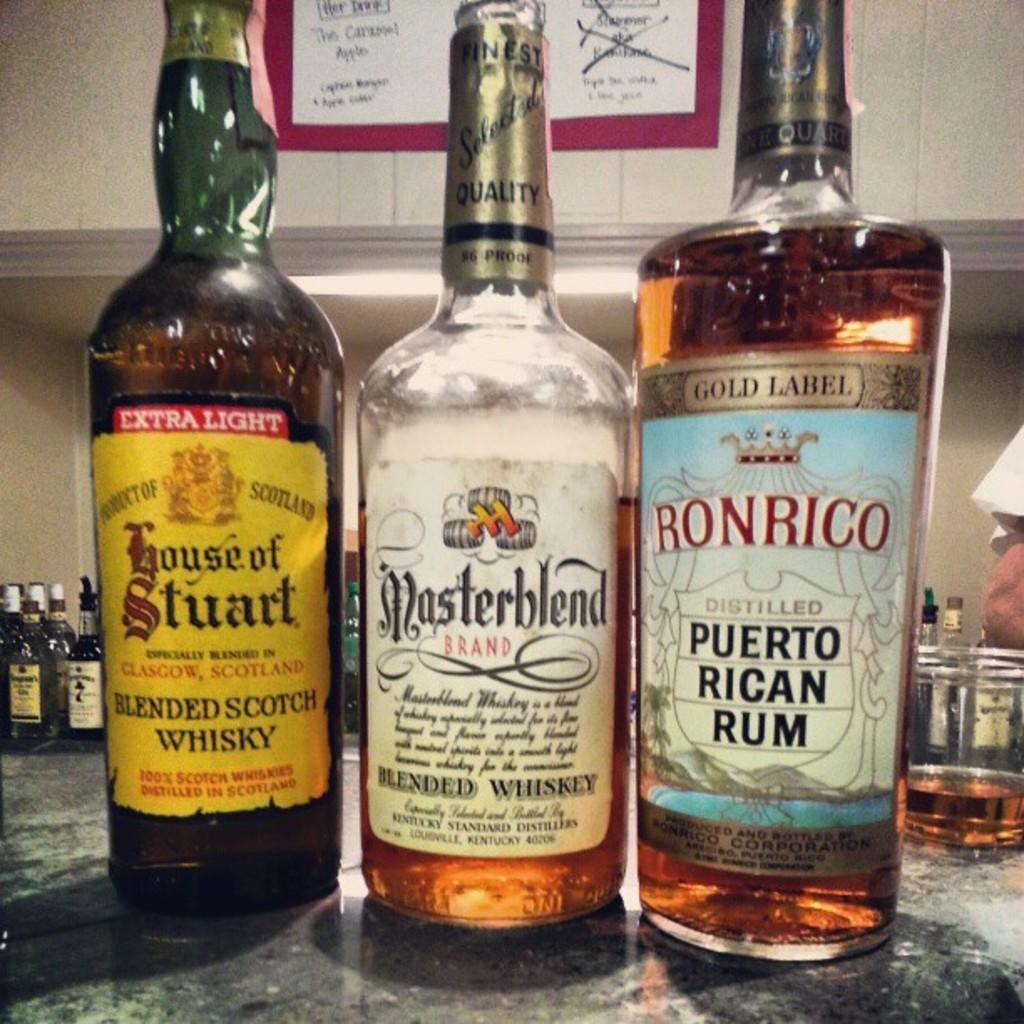<image>
Create a compact narrative representing the image presented. a Puerto Rican Rum bottle that has a tag on it 